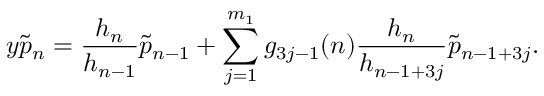<formula> <loc_0><loc_0><loc_500><loc_500>y \tilde { p } _ { n } = \frac { h _ { n } } { h _ { n - 1 } } \tilde { p } _ { n - 1 } + \sum _ { j = 1 } ^ { m _ { 1 } } g _ { 3 j - 1 } ( n ) \frac { h _ { n } } { h _ { n - 1 + 3 j } } \tilde { p } _ { n - 1 + 3 j } .</formula> 